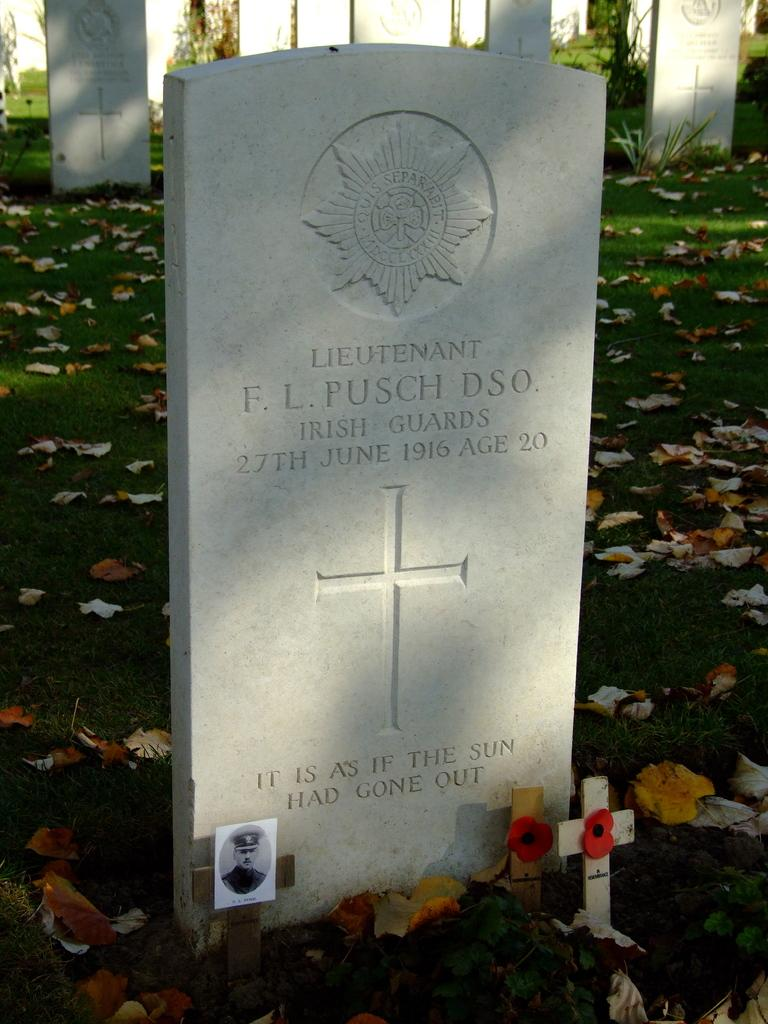What type of structures are present in the image? There are graves in the image. What can be found on the graves? The graves have text and logos. What religious symbol is visible in the image? There is a cross in the image. What covers the ground at the bottom of the image? The ground at the bottom of the image is covered with leaves. What type of paper is being used to create a snow turkey in the image? There is no paper, snow, or turkey present in the image. 